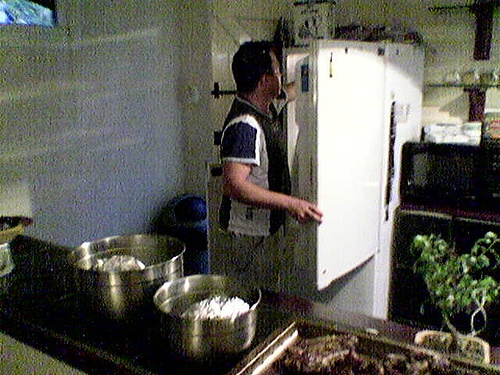Describe the objects in this image and their specific colors. I can see refrigerator in teal, white, gray, darkgray, and black tones, people in teal, black, gray, and maroon tones, potted plant in teal, black, darkgreen, and gray tones, and microwave in teal, black, gray, and darkgreen tones in this image. 